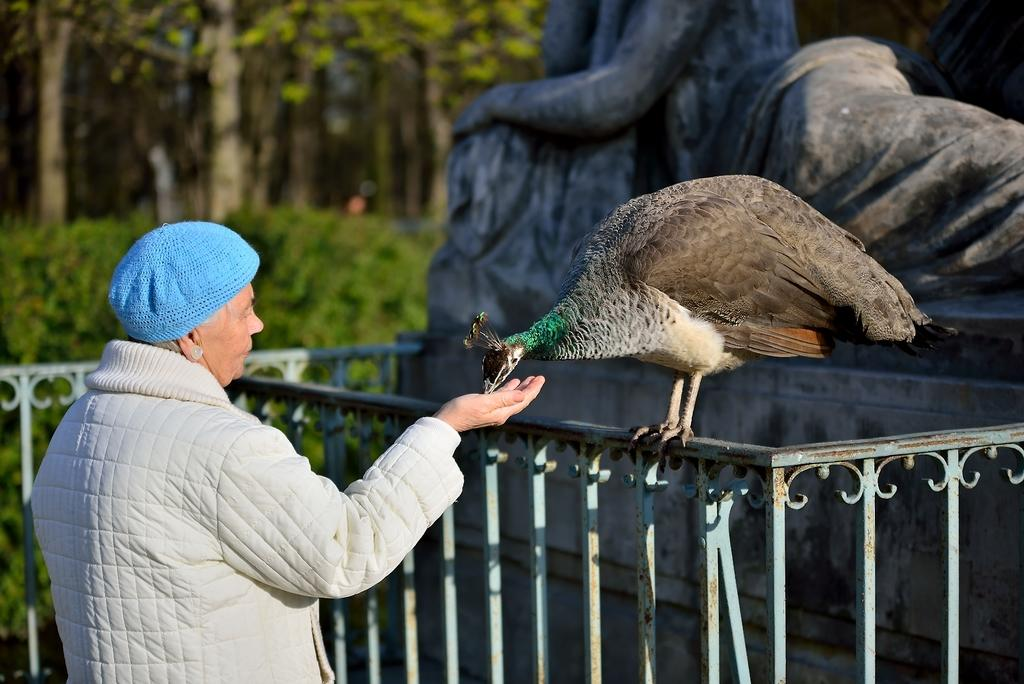What is the main subject in the image? There is a statue in the image. What animal can be seen in the image? There is a peacock standing on a fence in the image. Can you describe the person in the image? The person is wearing a cap and a jacket in the image. What type of vegetation is visible in the background of the image? There are trees in the background of the image. How would you describe the background of the image? The background of the image is blurry. What type of stamp can be seen on the peacock's feathers in the image? There is no stamp visible on the peacock's feathers in the image. What type of worm is crawling on the statue in the image? There are no worms present in the image. 